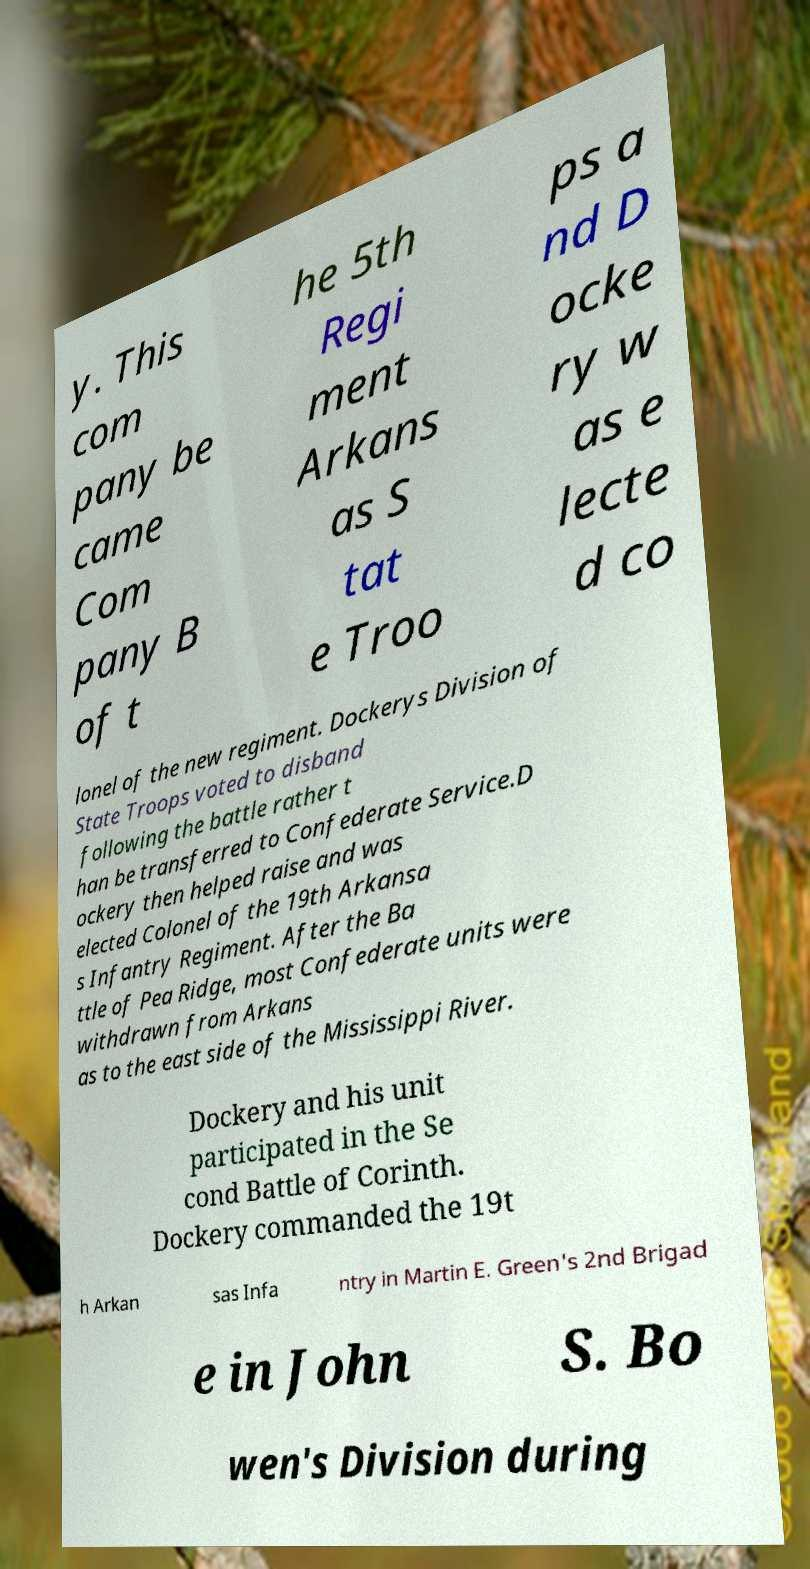Can you accurately transcribe the text from the provided image for me? y. This com pany be came Com pany B of t he 5th Regi ment Arkans as S tat e Troo ps a nd D ocke ry w as e lecte d co lonel of the new regiment. Dockerys Division of State Troops voted to disband following the battle rather t han be transferred to Confederate Service.D ockery then helped raise and was elected Colonel of the 19th Arkansa s Infantry Regiment. After the Ba ttle of Pea Ridge, most Confederate units were withdrawn from Arkans as to the east side of the Mississippi River. Dockery and his unit participated in the Se cond Battle of Corinth. Dockery commanded the 19t h Arkan sas Infa ntry in Martin E. Green's 2nd Brigad e in John S. Bo wen's Division during 